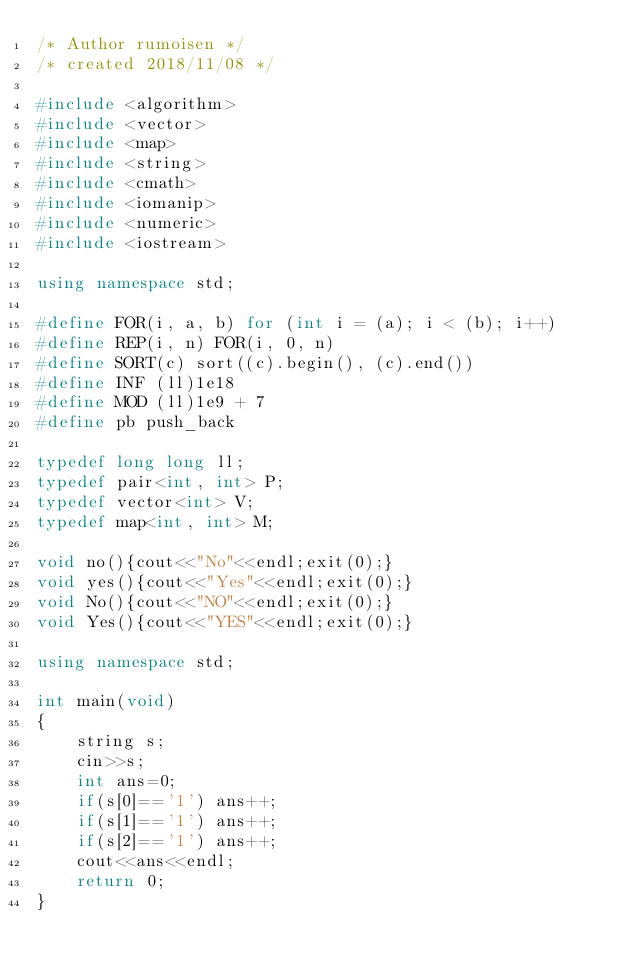Convert code to text. <code><loc_0><loc_0><loc_500><loc_500><_C++_>/* Author rumoisen */
/* created 2018/11/08 */

#include <algorithm>
#include <vector>
#include <map>
#include <string>
#include <cmath>
#include <iomanip>
#include <numeric>
#include <iostream>

using namespace std;
 
#define FOR(i, a, b) for (int i = (a); i < (b); i++)
#define REP(i, n) FOR(i, 0, n)
#define SORT(c) sort((c).begin(), (c).end())
#define INF (ll)1e18
#define MOD (ll)1e9 + 7
#define pb push_back

typedef long long ll;
typedef pair<int, int> P;
typedef vector<int> V;
typedef map<int, int> M;

void no(){cout<<"No"<<endl;exit(0);}
void yes(){cout<<"Yes"<<endl;exit(0);}
void No(){cout<<"NO"<<endl;exit(0);}
void Yes(){cout<<"YES"<<endl;exit(0);}

using namespace std;

int main(void)
{
    string s;
    cin>>s;
    int ans=0;
    if(s[0]=='1') ans++;
    if(s[1]=='1') ans++;
    if(s[2]=='1') ans++;
    cout<<ans<<endl;
    return 0; 
}</code> 